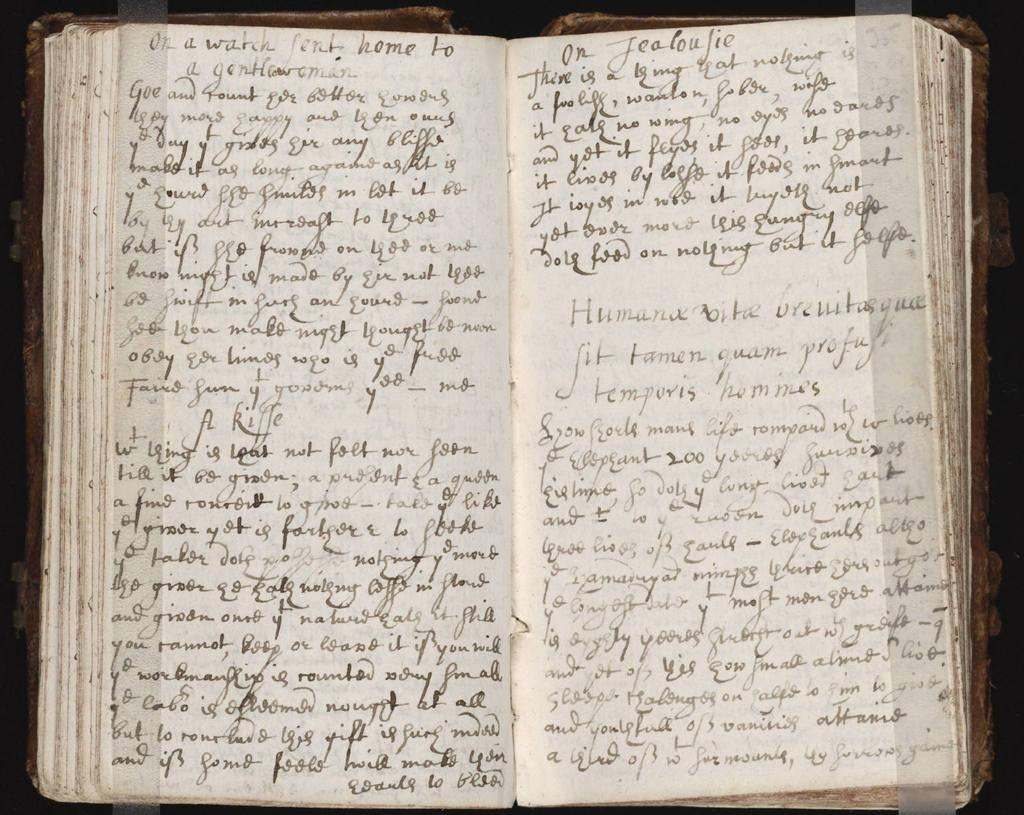<image>
Provide a brief description of the given image. The first words in this written journal are On a watch. 